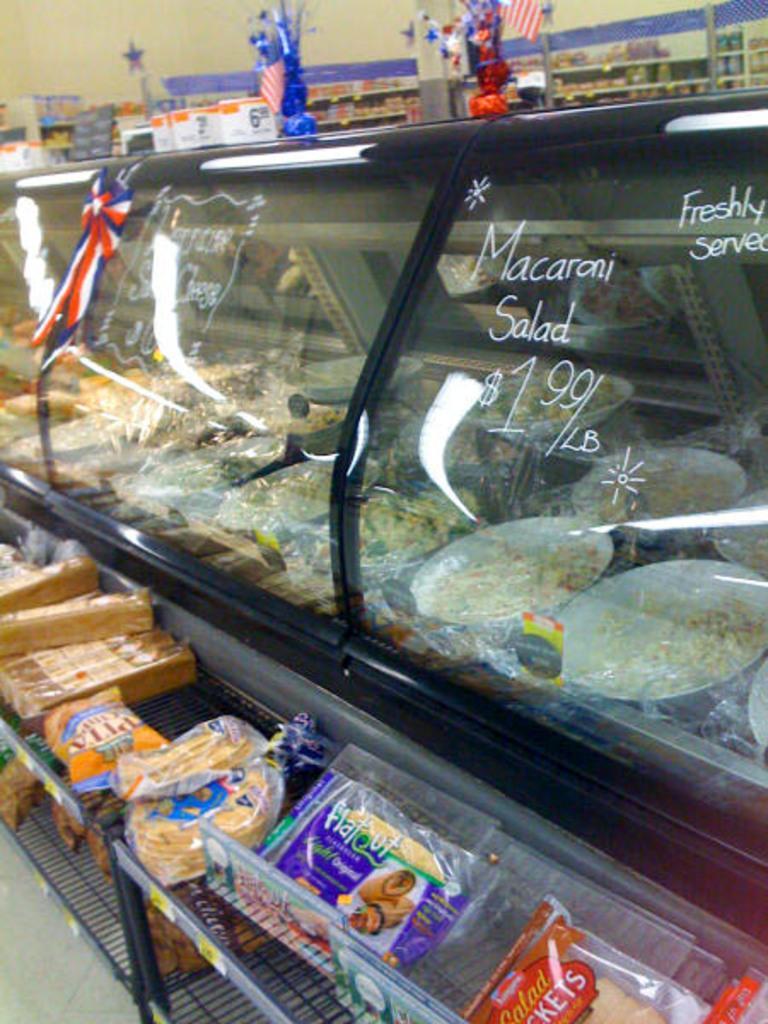How would you summarize this image in a sentence or two? In the middle of the image we can see some food items in the glass and some text written on the glass. We can see some baked items kept in a metal rack at the bottom of the image and we can see walls and things at the top of the image. 